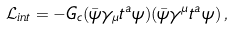Convert formula to latex. <formula><loc_0><loc_0><loc_500><loc_500>\mathcal { L } _ { i n t } = - G _ { c } ( \bar { \psi } \gamma _ { \mu } t ^ { a } \psi ) ( \bar { \psi } \gamma ^ { \mu } t ^ { a } \psi ) \, ,</formula> 